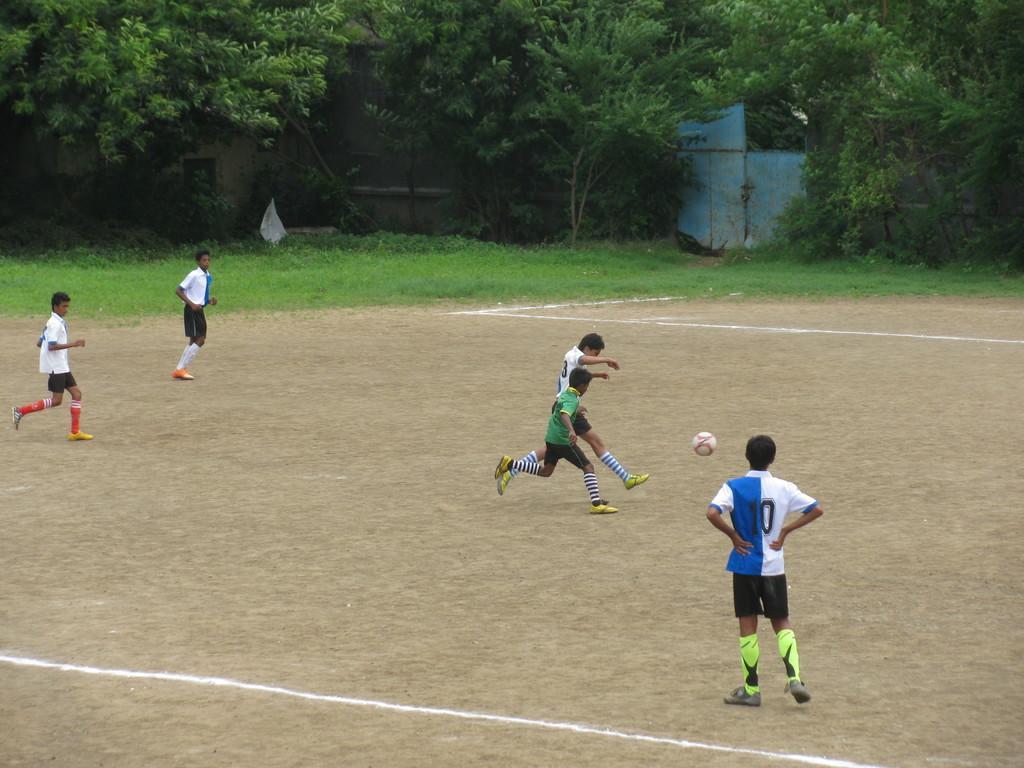Could you give a brief overview of what you see in this image? In this image I can see there are four boys running on the ground and on the right side a boy standing on the ground and I can see a ball in the middle and at the top I can see trees and I can see a blue color gate visible in the middle of trees and I can see green color grass in the ground. 